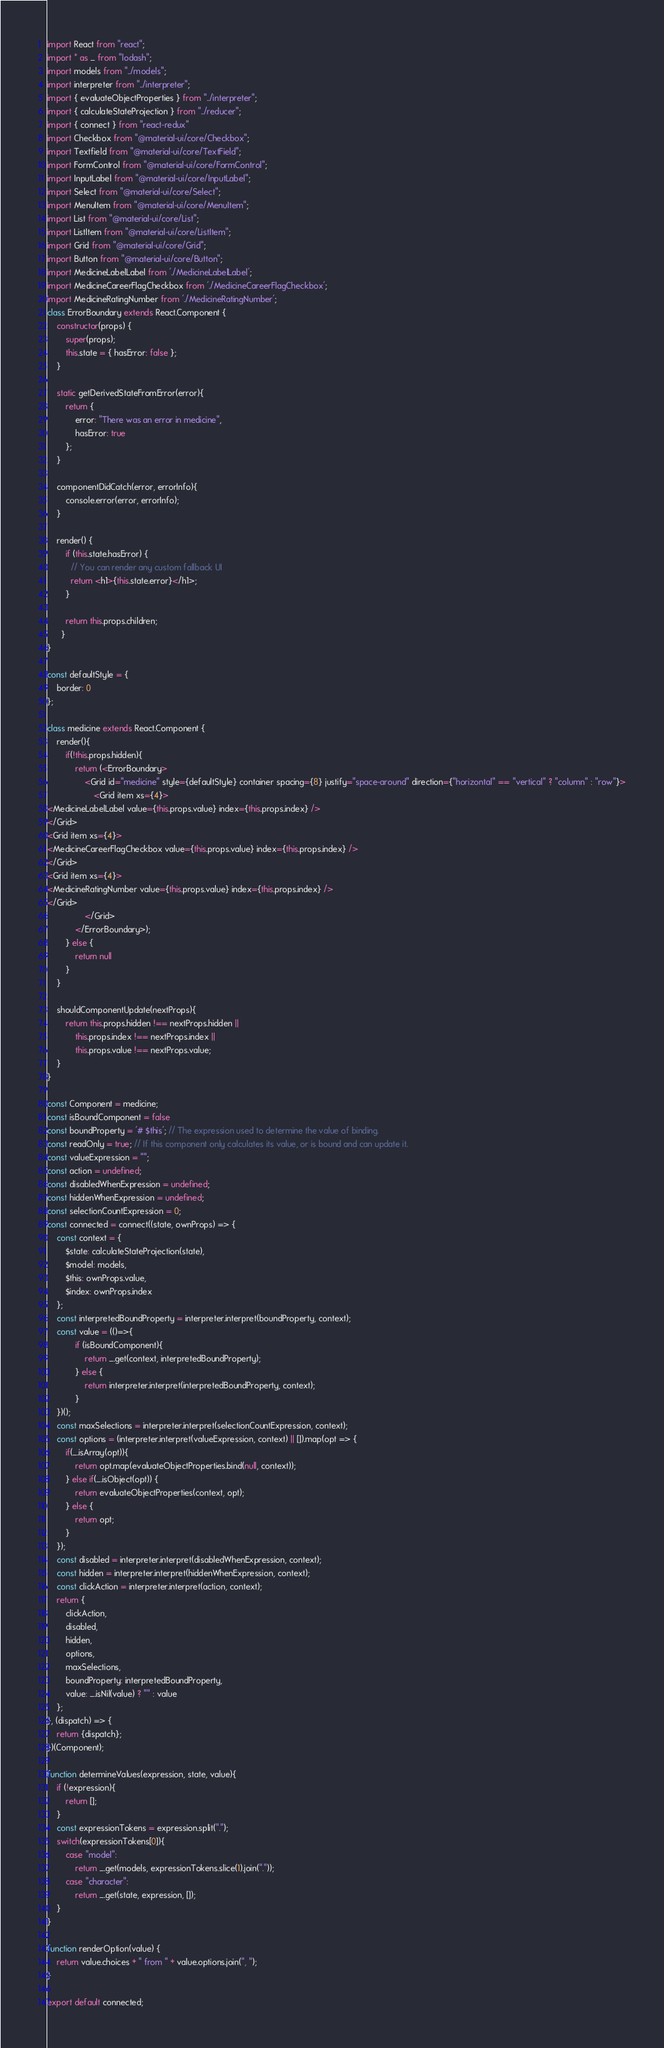<code> <loc_0><loc_0><loc_500><loc_500><_JavaScript_>import React from "react";
import * as _ from "lodash";
import models from "../models";
import interpreter from "../interpreter";
import { evaluateObjectProperties } from "../interpreter";
import { calculateStateProjection } from "../reducer";
import { connect } from "react-redux"
import Checkbox from "@material-ui/core/Checkbox";
import Textfield from "@material-ui/core/TextField";
import FormControl from "@material-ui/core/FormControl";
import InputLabel from "@material-ui/core/InputLabel";
import Select from "@material-ui/core/Select";
import MenuItem from "@material-ui/core/MenuItem";
import List from "@material-ui/core/List";
import ListItem from "@material-ui/core/ListItem";
import Grid from "@material-ui/core/Grid";
import Button from "@material-ui/core/Button";
import MedicineLabelLabel from './MedicineLabelLabel';
import MedicineCareerFlagCheckbox from './MedicineCareerFlagCheckbox';
import MedicineRatingNumber from './MedicineRatingNumber';
class ErrorBoundary extends React.Component {
    constructor(props) {
        super(props);
        this.state = { hasError: false };
    }

    static getDerivedStateFromError(error){
        return {
            error: "There was an error in medicine",
            hasError: true
        };
    }

    componentDidCatch(error, errorInfo){
        console.error(error, errorInfo);
    }

    render() {
        if (this.state.hasError) {
          // You can render any custom fallback UI
          return <h1>{this.state.error}</h1>;
        }

        return this.props.children;
      }
}

const defaultStyle = {
    border: 0
};

class medicine extends React.Component {
    render(){
        if(!this.props.hidden){
            return (<ErrorBoundary>
                <Grid id="medicine" style={defaultStyle} container spacing={8} justify="space-around" direction={"horizontal" == "vertical" ? "column" : "row"}>
                    <Grid item xs={4}>
<MedicineLabelLabel value={this.props.value} index={this.props.index} />
</Grid>
<Grid item xs={4}>
<MedicineCareerFlagCheckbox value={this.props.value} index={this.props.index} />
</Grid>
<Grid item xs={4}>
<MedicineRatingNumber value={this.props.value} index={this.props.index} />
</Grid>
                </Grid>
            </ErrorBoundary>);
        } else {
            return null
        }
    }

    shouldComponentUpdate(nextProps){
        return this.props.hidden !== nextProps.hidden ||
            this.props.index !== nextProps.index ||
            this.props.value !== nextProps.value;
    }
}

const Component = medicine;
const isBoundComponent = false
const boundProperty = '# $this'; // The expression used to determine the value of binding.
const readOnly = true; // If this component only calculates its value, or is bound and can update it.
const valueExpression = "";
const action = undefined;
const disabledWhenExpression = undefined;
const hiddenWhenExpression = undefined;
const selectionCountExpression = 0;
const connected = connect((state, ownProps) => {
    const context = {
        $state: calculateStateProjection(state),
        $model: models,
        $this: ownProps.value,
        $index: ownProps.index
    };
    const interpretedBoundProperty = interpreter.interpret(boundProperty, context);
    const value = (()=>{
            if (isBoundComponent){
                return _.get(context, interpretedBoundProperty);
            } else {
                return interpreter.interpret(interpretedBoundProperty, context);
            }
    })();
    const maxSelections = interpreter.interpret(selectionCountExpression, context);
    const options = (interpreter.interpret(valueExpression, context) || []).map(opt => {
        if(_.isArray(opt)){
            return opt.map(evaluateObjectProperties.bind(null, context));
        } else if(_.isObject(opt)) {
            return evaluateObjectProperties(context, opt);
        } else {
            return opt;
        }
    });
    const disabled = interpreter.interpret(disabledWhenExpression, context);
    const hidden = interpreter.interpret(hiddenWhenExpression, context);
    const clickAction = interpreter.interpret(action, context);
    return {
        clickAction,
        disabled,
        hidden,
        options,
        maxSelections,
        boundProperty: interpretedBoundProperty,
        value: _.isNil(value) ? "" : value
    };
}, (dispatch) => {
    return {dispatch};
})(Component);

function determineValues(expression, state, value){
    if (!expression){
        return [];
    }
    const expressionTokens = expression.split(".");
    switch(expressionTokens[0]){
        case "model":
            return _.get(models, expressionTokens.slice(1).join("."));
        case "character":
            return _.get(state, expression, []);
    }
}

function renderOption(value) {
    return value.choices + " from " + value.options.join(", ");
}

export default connected;</code> 